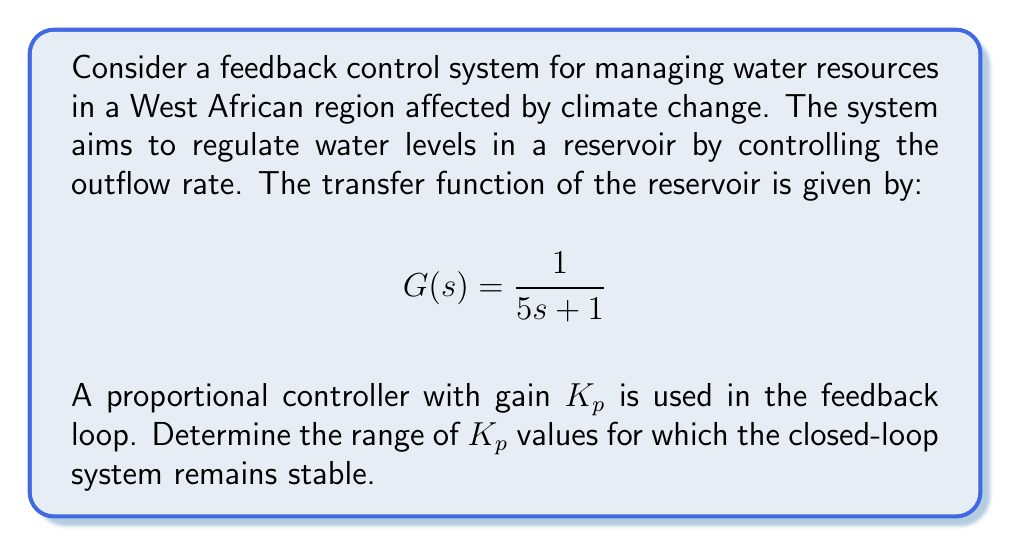Show me your answer to this math problem. To analyze the stability of this feedback control system, we'll use the Routh-Hurwitz stability criterion. Let's follow these steps:

1) First, we need to find the closed-loop transfer function. The general form is:

   $$T(s) = \frac{G(s)}{1 + G(s)H(s)}$$

   where $H(s) = K_p$ (the proportional controller)

2) Substituting the given $G(s)$ and $H(s)$:

   $$T(s) = \frac{\frac{1}{5s + 1}}{1 + \frac{1}{5s + 1}K_p} = \frac{1}{5s + 1 + K_p}$$

3) The characteristic equation is the denominator of $T(s)$ set to zero:

   $$5s + 1 + K_p = 0$$

4) Rearranging to standard form:

   $$5s + (1 + K_p) = 0$$

5) Now we can create the Routh array:

   $$\begin{array}{c|c}
   s^1 & 5 \\
   s^0 & 1 + K_p
   \end{array}$$

6) For stability, all elements in the first column of the Routh array must be positive. We already know that 5 > 0, so we need:

   $$1 + K_p > 0$$

7) Solving this inequality:

   $$K_p > -1$$

Therefore, the system is stable for all $K_p > -1$.

This result is particularly relevant for water resource management in West Africa, where climate change is causing more frequent droughts and floods. A stable control system ensures that water levels can be managed effectively despite these fluctuations, supporting both ecological balance and human needs.
Answer: The closed-loop system remains stable for all $K_p > -1$. 